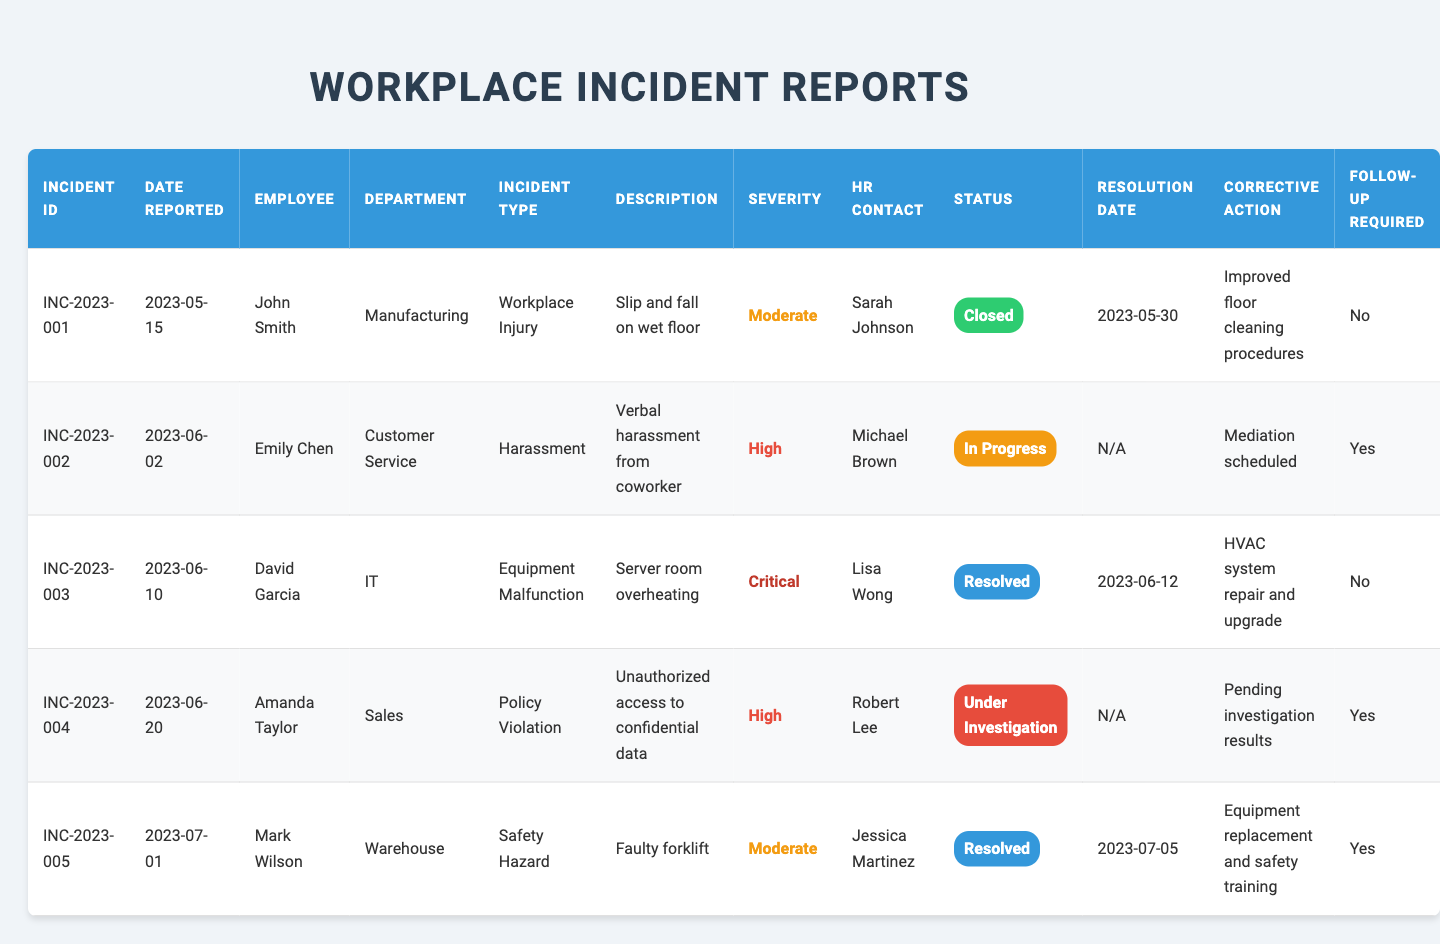What is the incident ID for the incident reported by Emily Chen? Look at the row where the employee's name is Emily Chen, which corresponds to the incident ID shown in the same row. The incident ID is INC-2023-002.
Answer: INC-2023-002 How many incidents are marked as "Resolved"? By scanning the resolution status column, we count how many entries have "Resolved" as their status. There are 2 incidents marked as "Resolved" (INC-2023-003 and INC-2023-005).
Answer: 2 Which incident had the highest severity rating? The severity ratings are listed as Moderate, High, and Critical. Looking for the highest indicates we look for "Critical" in the severity column, which corresponds to incident INC-2023-003.
Answer: INC-2023-003 What corrective action was taken for the incident involving John Smith? Find the row corresponding to John Smith and look at the "Corrective Action" column. The corrective action listed is "Improved floor cleaning procedures."
Answer: Improved floor cleaning procedures Is there any follow-up required for the incident involving Amanda Taylor? Check the "Follow-up Required" column for Amanda Taylor. It shows "Yes," indicating that follow-up is necessary.
Answer: Yes How many incidents are currently "In Progress" or "Under Investigation"? Count the incidents where status is "In Progress" or "Under Investigation." There is 1 in progress (INC-2023-002) and 1 under investigation (INC-2023-004), totaling 2 incidents.
Answer: 2 Which department reported the critical incident? The critical incident corresponds to a severity of "Critical" in the table, which is linked to incident INC-2023-003. The department associated with this incident is IT.
Answer: IT What resolution date was recorded for the resolved incident with the lowest severity? Look through the resolved incidents (INC-2023-003 and INC-2023-005) and find the lowest severity, which is "Moderate" for INC-2023-005, resolved on 2023-07-05.
Answer: 2023-07-05 Do all incidents have an HR contact listed? By checking each row, we see that every incident has an HR contact name associated with it. Therefore, we conclude that all incidents do have HR contacts listed.
Answer: Yes What corrective action was taken for the incident categorized as harassment? Find the row where the incident type is "Harassment," which corresponds to incident INC-2023-002. The corrective action listed is "Mediation scheduled."
Answer: Mediation scheduled How many incidents involve follow-up requirements in the Manufacturing department? Check all incidents in the Manufacturing department and look for those where follow-up is required. There is 1 incident (INC-2023-001) from the Manufacturing department, and it indicates no follow-up necessary.
Answer: 0 What is the most frequent incident type reported based on the table? Review the "Incident Type" column and identify which type appears most frequently. "Workplace Injury" and "Harassment" appear each once, while "Safety Hazard" appears once too; thus, no type is distinctly more frequent than others regarding unique entries.
Answer: No frequency variance 